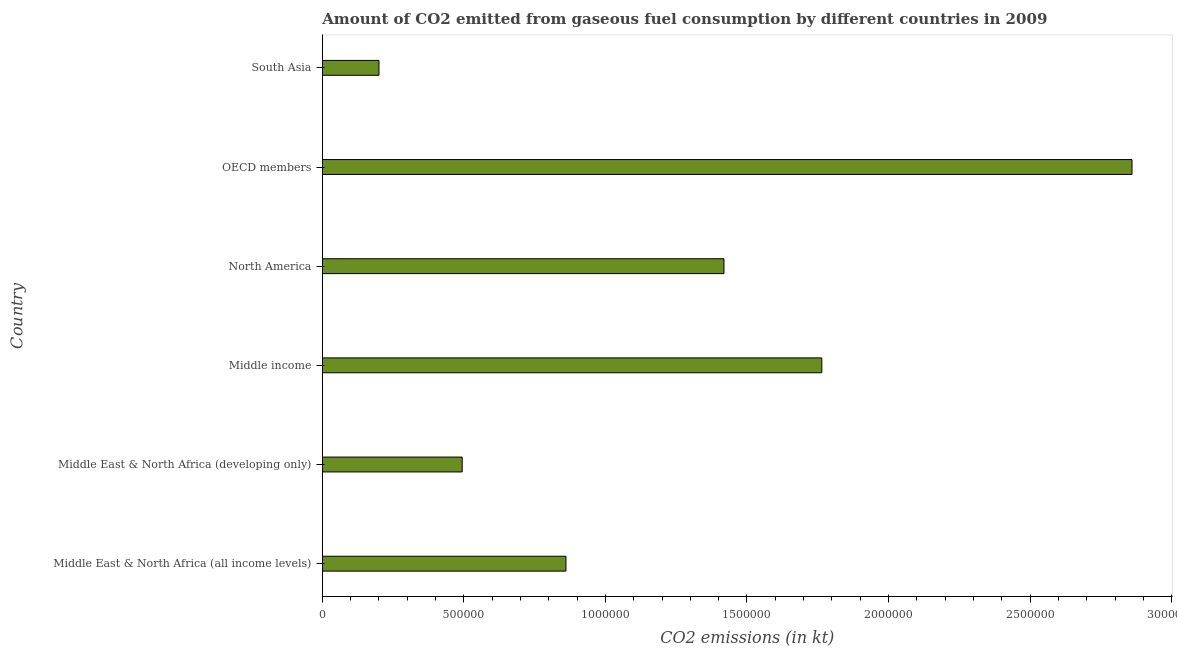Does the graph contain any zero values?
Offer a terse response. No. Does the graph contain grids?
Your answer should be compact. No. What is the title of the graph?
Give a very brief answer. Amount of CO2 emitted from gaseous fuel consumption by different countries in 2009. What is the label or title of the X-axis?
Offer a terse response. CO2 emissions (in kt). What is the co2 emissions from gaseous fuel consumption in South Asia?
Your answer should be compact. 2.00e+05. Across all countries, what is the maximum co2 emissions from gaseous fuel consumption?
Keep it short and to the point. 2.86e+06. Across all countries, what is the minimum co2 emissions from gaseous fuel consumption?
Make the answer very short. 2.00e+05. In which country was the co2 emissions from gaseous fuel consumption maximum?
Provide a succinct answer. OECD members. In which country was the co2 emissions from gaseous fuel consumption minimum?
Make the answer very short. South Asia. What is the sum of the co2 emissions from gaseous fuel consumption?
Your answer should be compact. 7.60e+06. What is the difference between the co2 emissions from gaseous fuel consumption in Middle East & North Africa (developing only) and South Asia?
Your answer should be compact. 2.94e+05. What is the average co2 emissions from gaseous fuel consumption per country?
Your response must be concise. 1.27e+06. What is the median co2 emissions from gaseous fuel consumption?
Your answer should be very brief. 1.14e+06. What is the ratio of the co2 emissions from gaseous fuel consumption in North America to that in South Asia?
Give a very brief answer. 7.09. What is the difference between the highest and the second highest co2 emissions from gaseous fuel consumption?
Your response must be concise. 1.10e+06. What is the difference between the highest and the lowest co2 emissions from gaseous fuel consumption?
Give a very brief answer. 2.66e+06. How many countries are there in the graph?
Provide a succinct answer. 6. Are the values on the major ticks of X-axis written in scientific E-notation?
Offer a very short reply. No. What is the CO2 emissions (in kt) of Middle East & North Africa (all income levels)?
Provide a short and direct response. 8.61e+05. What is the CO2 emissions (in kt) of Middle East & North Africa (developing only)?
Provide a succinct answer. 4.94e+05. What is the CO2 emissions (in kt) in Middle income?
Your answer should be very brief. 1.76e+06. What is the CO2 emissions (in kt) of North America?
Your answer should be compact. 1.42e+06. What is the CO2 emissions (in kt) in OECD members?
Your answer should be very brief. 2.86e+06. What is the CO2 emissions (in kt) in South Asia?
Your answer should be very brief. 2.00e+05. What is the difference between the CO2 emissions (in kt) in Middle East & North Africa (all income levels) and Middle East & North Africa (developing only)?
Give a very brief answer. 3.67e+05. What is the difference between the CO2 emissions (in kt) in Middle East & North Africa (all income levels) and Middle income?
Provide a succinct answer. -9.04e+05. What is the difference between the CO2 emissions (in kt) in Middle East & North Africa (all income levels) and North America?
Keep it short and to the point. -5.58e+05. What is the difference between the CO2 emissions (in kt) in Middle East & North Africa (all income levels) and OECD members?
Offer a very short reply. -2.00e+06. What is the difference between the CO2 emissions (in kt) in Middle East & North Africa (all income levels) and South Asia?
Provide a short and direct response. 6.60e+05. What is the difference between the CO2 emissions (in kt) in Middle East & North Africa (developing only) and Middle income?
Your answer should be compact. -1.27e+06. What is the difference between the CO2 emissions (in kt) in Middle East & North Africa (developing only) and North America?
Your answer should be very brief. -9.25e+05. What is the difference between the CO2 emissions (in kt) in Middle East & North Africa (developing only) and OECD members?
Offer a terse response. -2.37e+06. What is the difference between the CO2 emissions (in kt) in Middle East & North Africa (developing only) and South Asia?
Your response must be concise. 2.94e+05. What is the difference between the CO2 emissions (in kt) in Middle income and North America?
Offer a terse response. 3.46e+05. What is the difference between the CO2 emissions (in kt) in Middle income and OECD members?
Provide a succinct answer. -1.10e+06. What is the difference between the CO2 emissions (in kt) in Middle income and South Asia?
Give a very brief answer. 1.56e+06. What is the difference between the CO2 emissions (in kt) in North America and OECD members?
Make the answer very short. -1.44e+06. What is the difference between the CO2 emissions (in kt) in North America and South Asia?
Your answer should be compact. 1.22e+06. What is the difference between the CO2 emissions (in kt) in OECD members and South Asia?
Provide a short and direct response. 2.66e+06. What is the ratio of the CO2 emissions (in kt) in Middle East & North Africa (all income levels) to that in Middle East & North Africa (developing only)?
Your answer should be compact. 1.74. What is the ratio of the CO2 emissions (in kt) in Middle East & North Africa (all income levels) to that in Middle income?
Give a very brief answer. 0.49. What is the ratio of the CO2 emissions (in kt) in Middle East & North Africa (all income levels) to that in North America?
Give a very brief answer. 0.61. What is the ratio of the CO2 emissions (in kt) in Middle East & North Africa (all income levels) to that in OECD members?
Offer a terse response. 0.3. What is the ratio of the CO2 emissions (in kt) in Middle East & North Africa (all income levels) to that in South Asia?
Offer a very short reply. 4.3. What is the ratio of the CO2 emissions (in kt) in Middle East & North Africa (developing only) to that in Middle income?
Your answer should be compact. 0.28. What is the ratio of the CO2 emissions (in kt) in Middle East & North Africa (developing only) to that in North America?
Offer a terse response. 0.35. What is the ratio of the CO2 emissions (in kt) in Middle East & North Africa (developing only) to that in OECD members?
Ensure brevity in your answer.  0.17. What is the ratio of the CO2 emissions (in kt) in Middle East & North Africa (developing only) to that in South Asia?
Your answer should be very brief. 2.47. What is the ratio of the CO2 emissions (in kt) in Middle income to that in North America?
Make the answer very short. 1.24. What is the ratio of the CO2 emissions (in kt) in Middle income to that in OECD members?
Offer a very short reply. 0.62. What is the ratio of the CO2 emissions (in kt) in Middle income to that in South Asia?
Ensure brevity in your answer.  8.82. What is the ratio of the CO2 emissions (in kt) in North America to that in OECD members?
Give a very brief answer. 0.5. What is the ratio of the CO2 emissions (in kt) in North America to that in South Asia?
Provide a succinct answer. 7.09. What is the ratio of the CO2 emissions (in kt) in OECD members to that in South Asia?
Your answer should be compact. 14.3. 